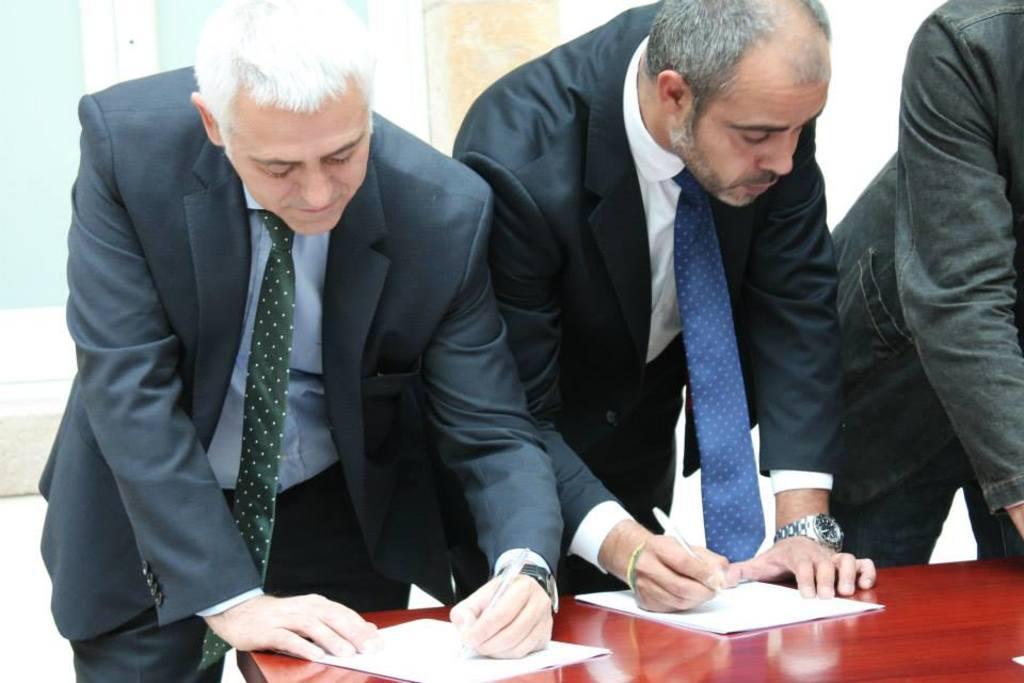Describe this image in one or two sentences. In this image I can see three people and I can see two of them are wearing formal dress. I can also see both of them are holding pens and here I can see few papers on this table. 